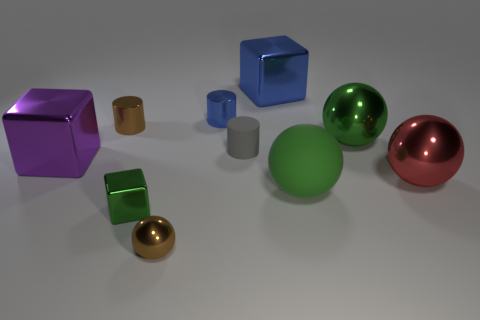What number of large shiny blocks have the same color as the tiny metal cube?
Offer a terse response. 0. The metal object that is behind the brown metal cylinder and to the right of the small blue shiny cylinder has what shape?
Offer a terse response. Cube. What is the color of the shiny cube that is both to the left of the tiny blue metallic cylinder and behind the big red metal ball?
Provide a short and direct response. Purple. Are there more large metallic things that are behind the small green metallic object than spheres that are on the left side of the small blue metal thing?
Make the answer very short. Yes. What color is the cube that is in front of the big red ball?
Make the answer very short. Green. Do the tiny brown metallic object that is on the left side of the tiny brown sphere and the large purple thing that is in front of the gray matte cylinder have the same shape?
Your response must be concise. No. Is there a metallic sphere of the same size as the purple thing?
Your answer should be very brief. Yes. What is the material of the green object to the left of the tiny gray cylinder?
Offer a very short reply. Metal. Is the green sphere that is behind the tiny rubber cylinder made of the same material as the big blue thing?
Ensure brevity in your answer.  Yes. Are there any blue blocks?
Keep it short and to the point. Yes. 